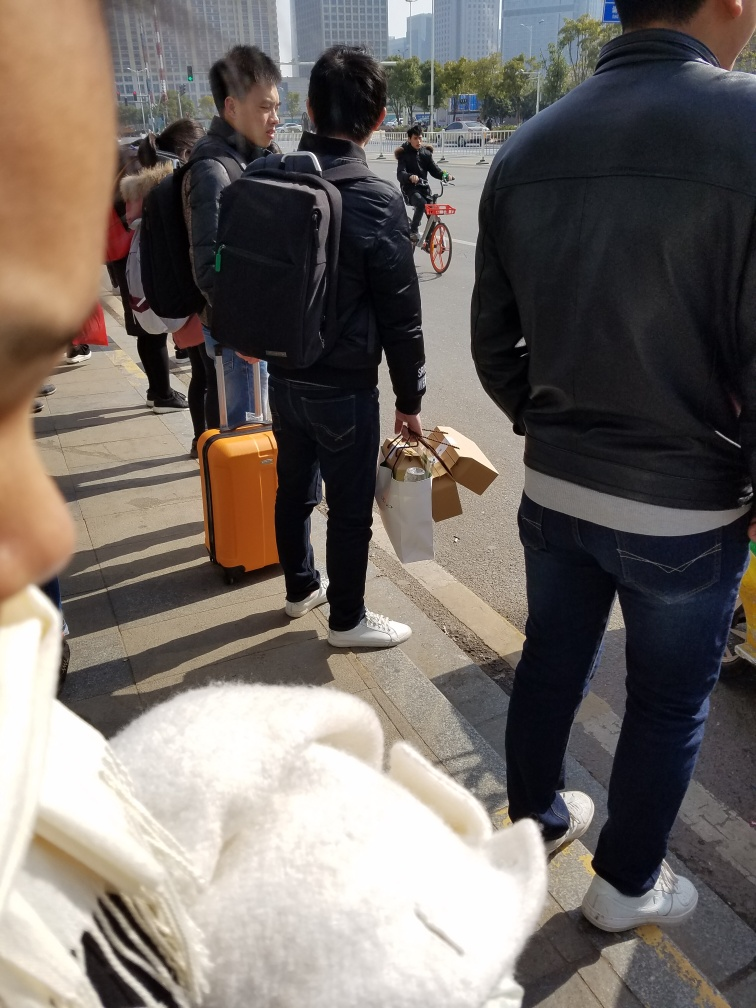What time of day does it seem to be in this image? Given the clear sky and the shadows cast by the people, it looks to be daytime, possibly morning or early afternoon. 